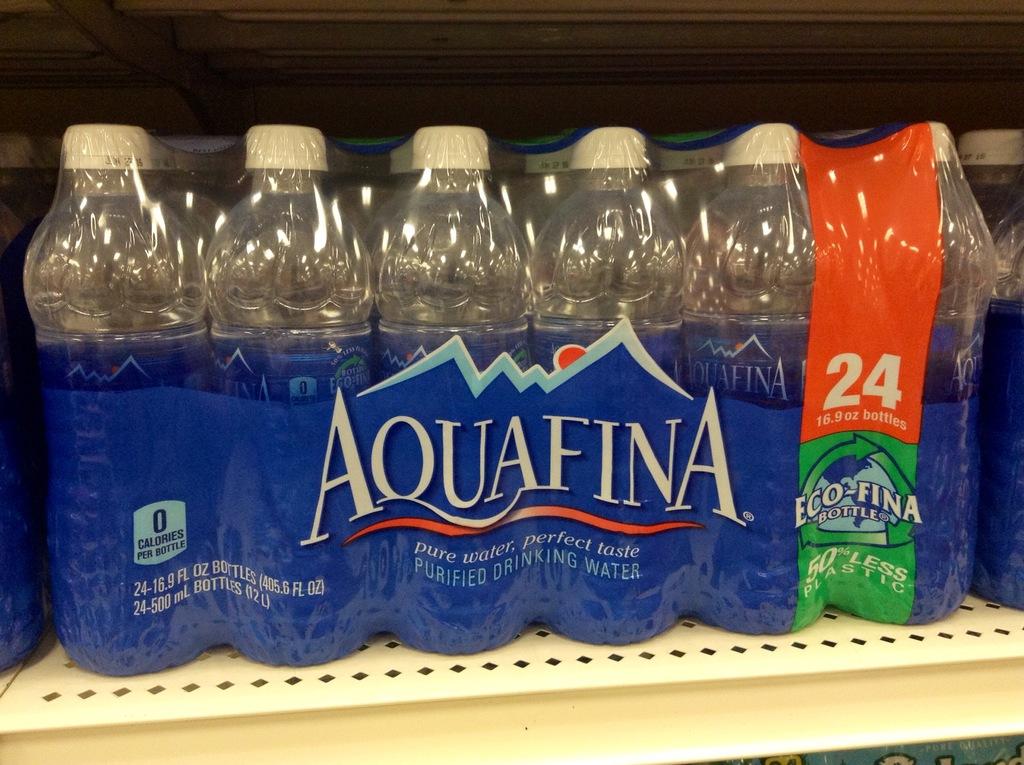What brand of water is this?
Keep it short and to the point. Aquafina. 